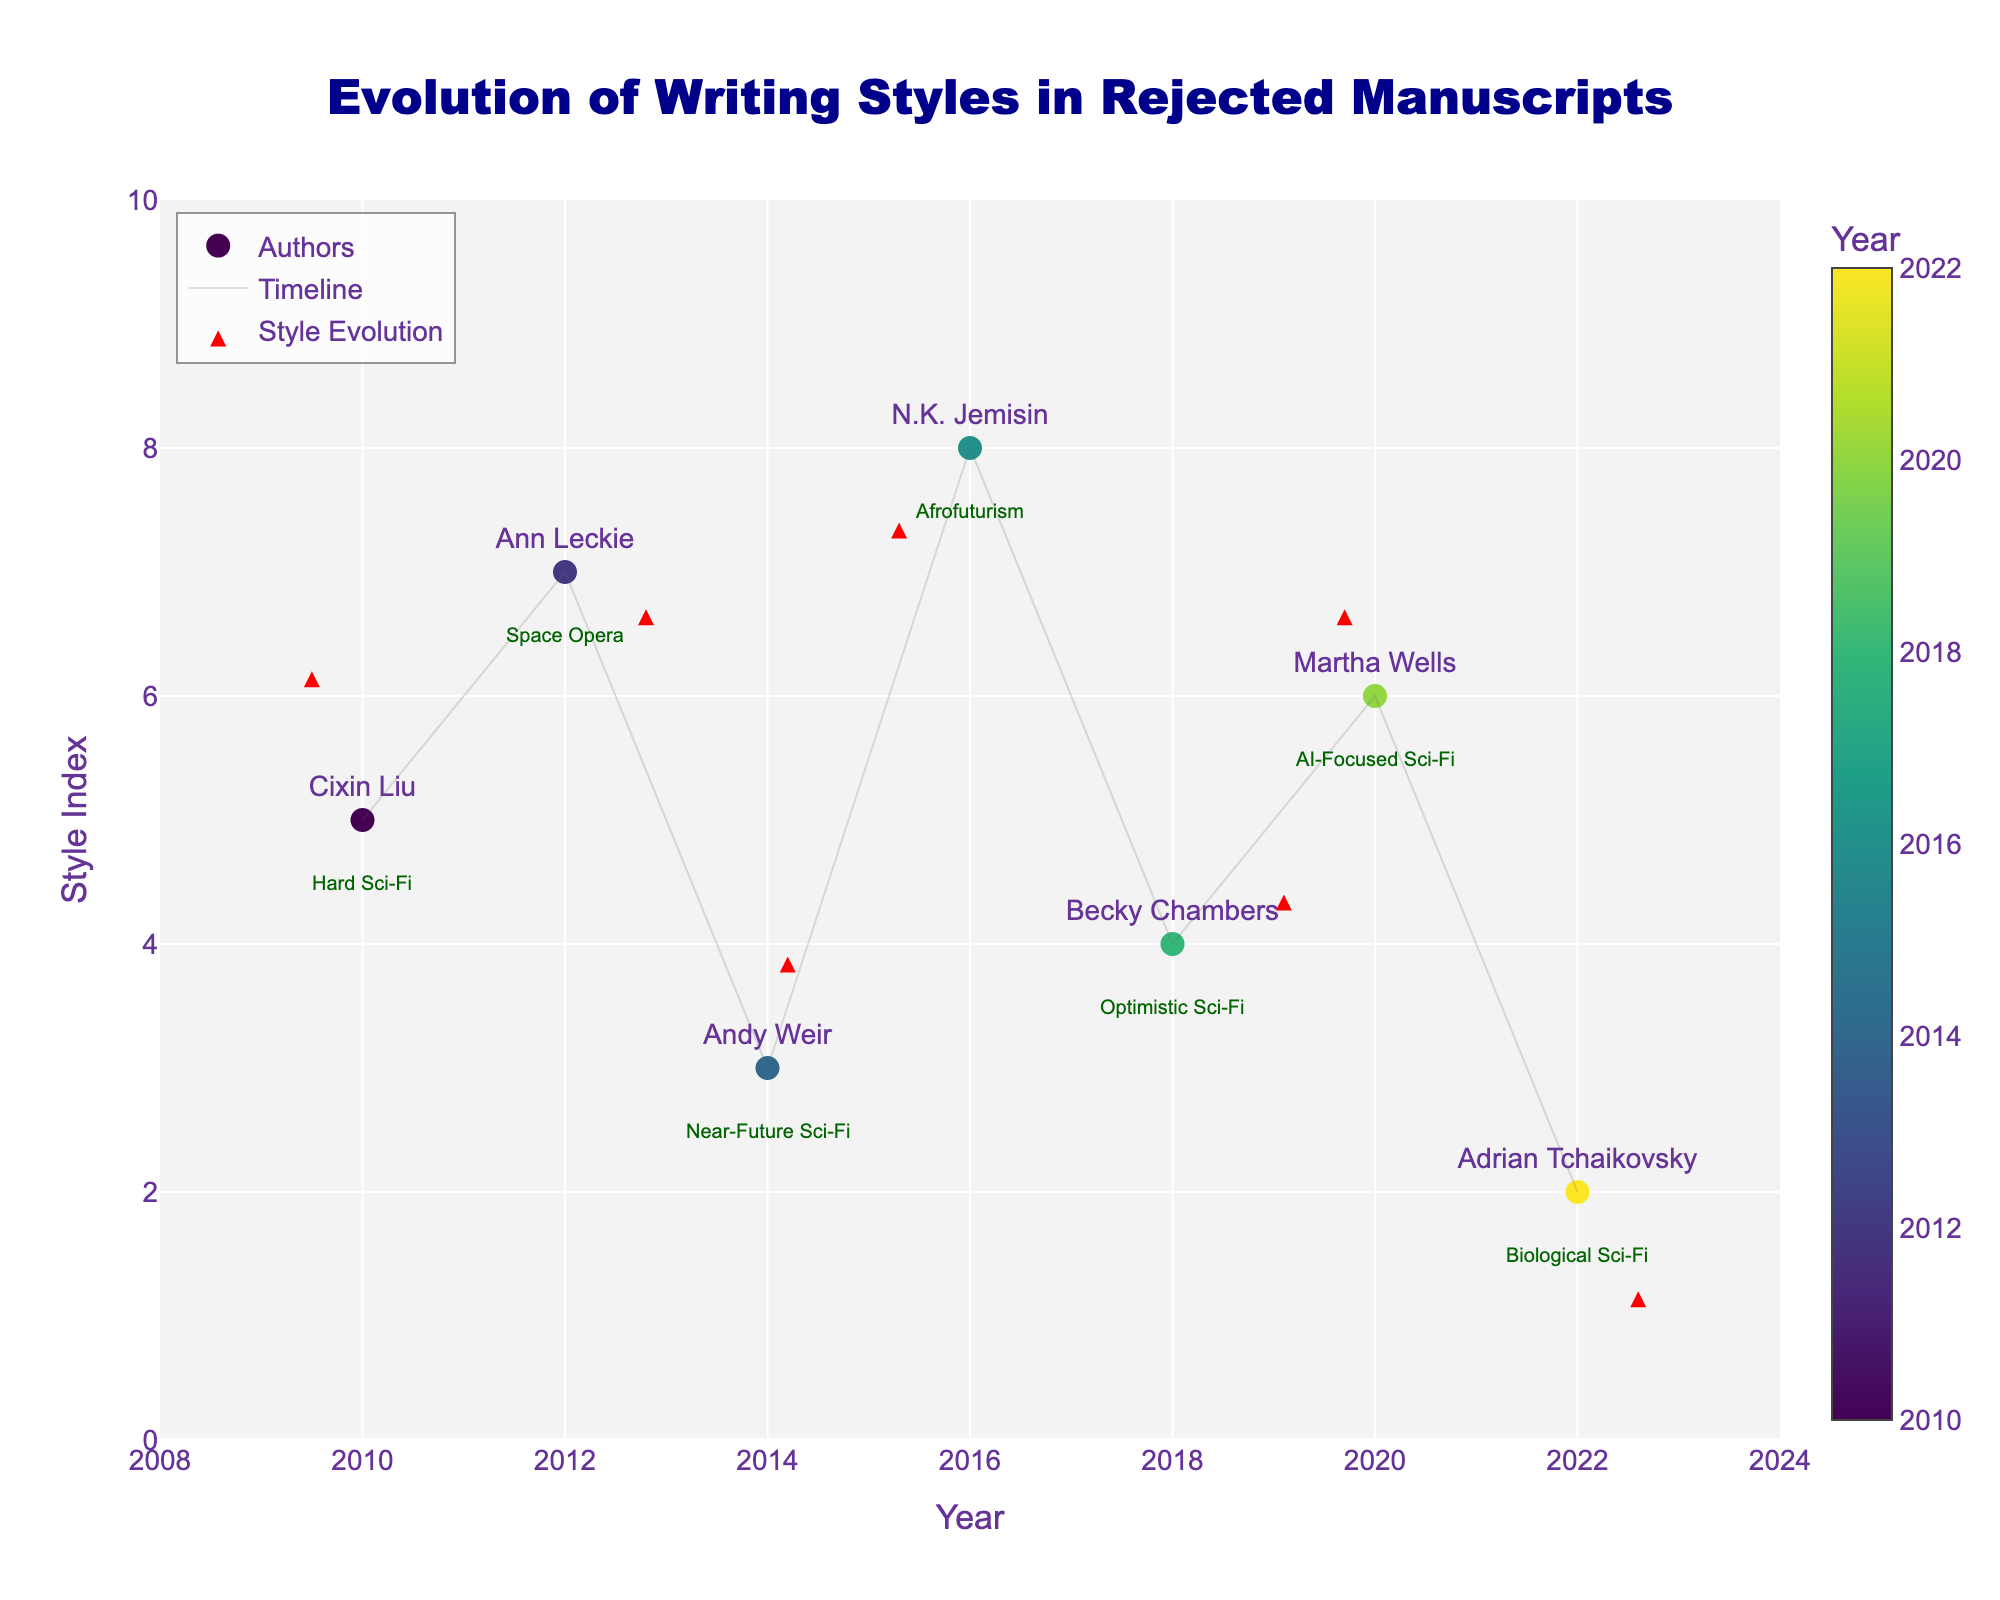What is the title of the figure? The title is clearly displayed at the top of the figure and reads "Evolution of Writing Styles in Rejected Manuscripts".
Answer: Evolution of Writing Styles in Rejected Manuscripts Which author is associated with 'Optimistic Sci-Fi'? Each data point is labeled with the author's name and genre. Becky Chambers' genre is listed as 'Optimistic Sci-Fi'.
Answer: Becky Chambers In 2012, did the writing style of the author become more formal or informal? We associate increases in the Style Index (Y-axis) with informality and decreases with formality. Ann Leckie's writing style at (2012, 7) changed with vectors (0.8, -0.3), resulting in a slightly more formal style.
Answer: More formal Which genre has the greatest increase in the Style Index over time? The direction of arrows on the plot indicates changes. "Near-Future Sci-Fi" by Andy Weir in 2014 shows a move from 3 to 3.9 along the Y-axis, which is the largest positive change.
Answer: Near-Future Sci-Fi Which author had their writing style move significantly towards primitive language use, based on the negative Y-component of their vector? The author associated with the most significant negative Y-component (decrease in style index) is Adrian Tchaikovsky with (0.6, -0.8).
Answer: Adrian Tchaikovsky How many authors' arrow tips (end points of the quiver vectors) fall between the years 2014 and 2018 on the X-axis? Analyze the position of the end points of the vectors. The data points for Andy Weir in 2014 and Becky Chambers in 2018 fall within this range.
Answer: 2 Which author shows a significant reduction in word choice complexity, indicated by a negative X-component? N.K. Jemisin's vector (-0.7, -0.6) shows the largest negative X-component, indicating a significant reduction in word choice complexity.
Answer: N.K. Jemisin Among the authors listed, whose writing style has an equally upward and rightward trend in terms of style index and year? We need to find an author whose vector has U and V components with a similar positive magnitude. Becky Chambers has (1.1, 0.4), corresponding closely to equal positive shifts.
Answer: Becky Chambers What is the average Style Index change for authors between 2010 and 2022? Calculate the average difference from initial to final Y-values. Values: 1.2, -0.3, 0.9, -0.6, 0.4, 0.7, -0.8. Sum is 1.5. Average is 1.5/7 ≈ 0.21.
Answer: 0.21 